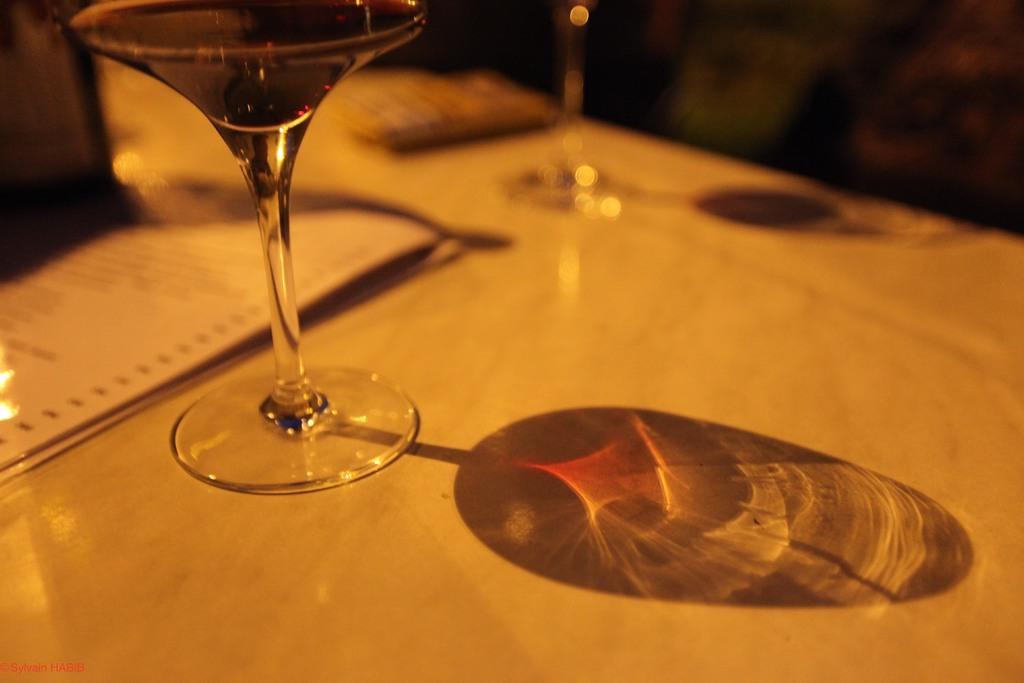Can you describe this image briefly? Here we can see glasses and papers on a platform. 